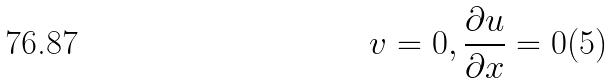<formula> <loc_0><loc_0><loc_500><loc_500>v = 0 , \frac { \partial u } { \partial x } = 0 ( 5 )</formula> 